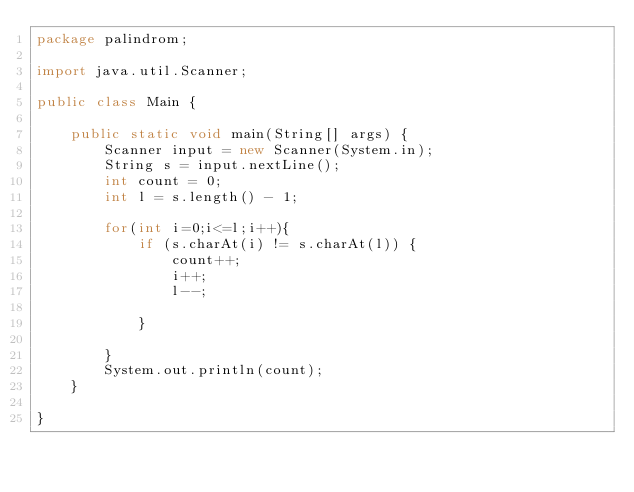Convert code to text. <code><loc_0><loc_0><loc_500><loc_500><_Java_>package palindrom;

import java.util.Scanner;

public class Main {

    public static void main(String[] args) {
        Scanner input = new Scanner(System.in);  
        String s = input.nextLine();
        int count = 0;
        int l = s.length() - 1;

        for(int i=0;i<=l;i++){
            if (s.charAt(i) != s.charAt(l)) {
                count++;
                i++;
                l--;

            }

        }
        System.out.println(count);
    }

}
</code> 